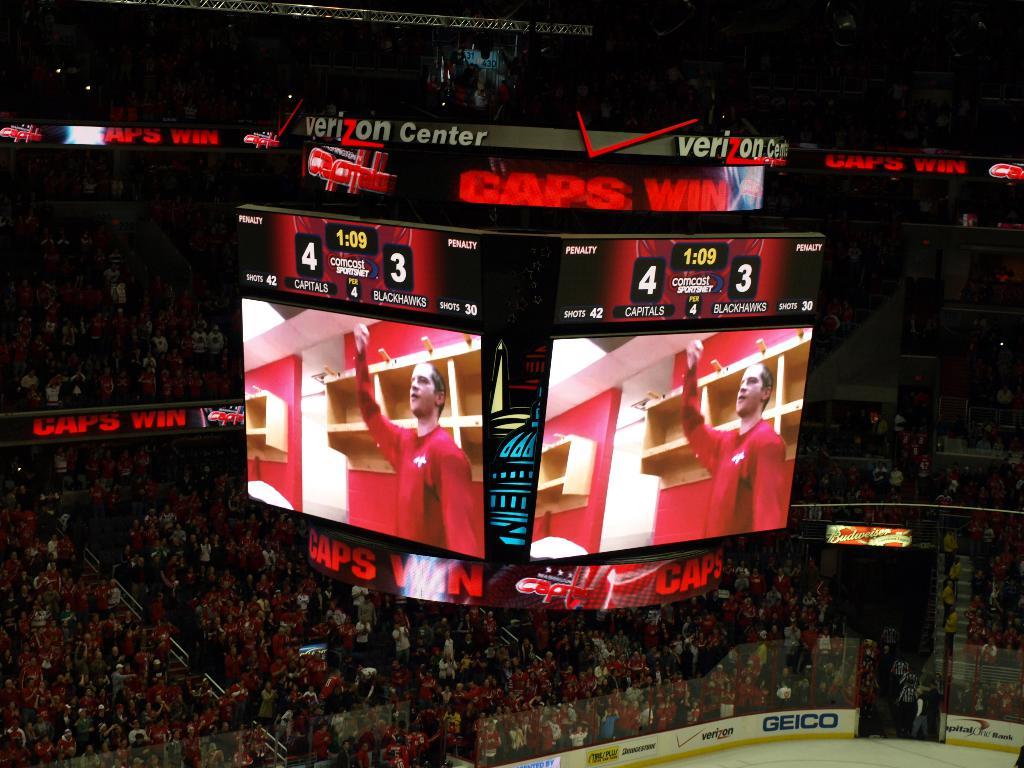Which team won?
Your answer should be very brief. Capitals. 